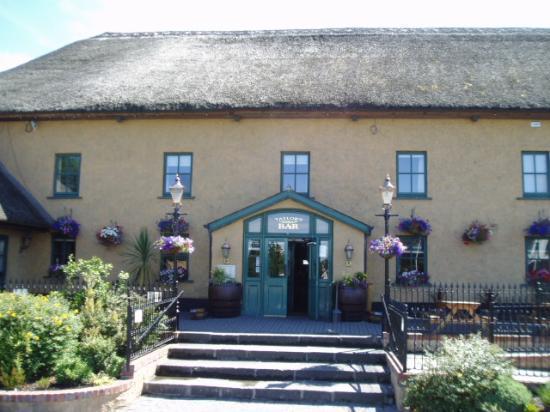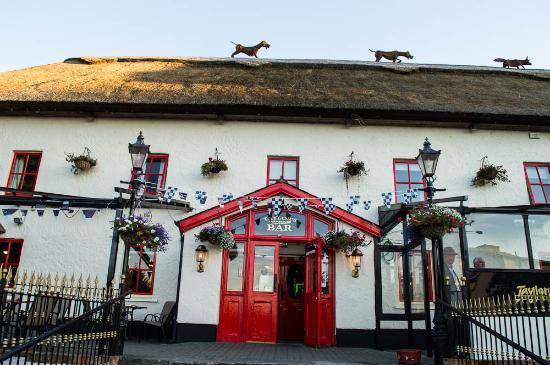The first image is the image on the left, the second image is the image on the right. Analyze the images presented: Is the assertion "There are wide, curved steps in front of the red door in the image on the left." valid? Answer yes or no. No. The first image is the image on the left, the second image is the image on the right. Analyze the images presented: Is the assertion "In one image, at least one rightward-facing dog figure is on the rooftop of a large, pale colored building with red entrance doors." valid? Answer yes or no. Yes. 